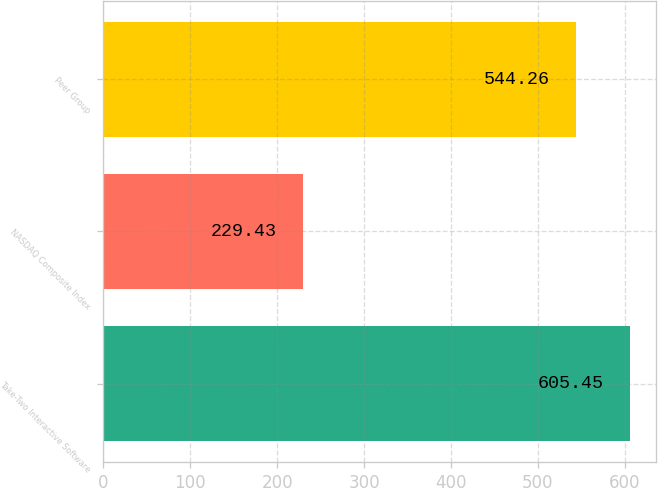<chart> <loc_0><loc_0><loc_500><loc_500><bar_chart><fcel>Take-Two Interactive Software<fcel>NASDAQ Composite Index<fcel>Peer Group<nl><fcel>605.45<fcel>229.43<fcel>544.26<nl></chart> 